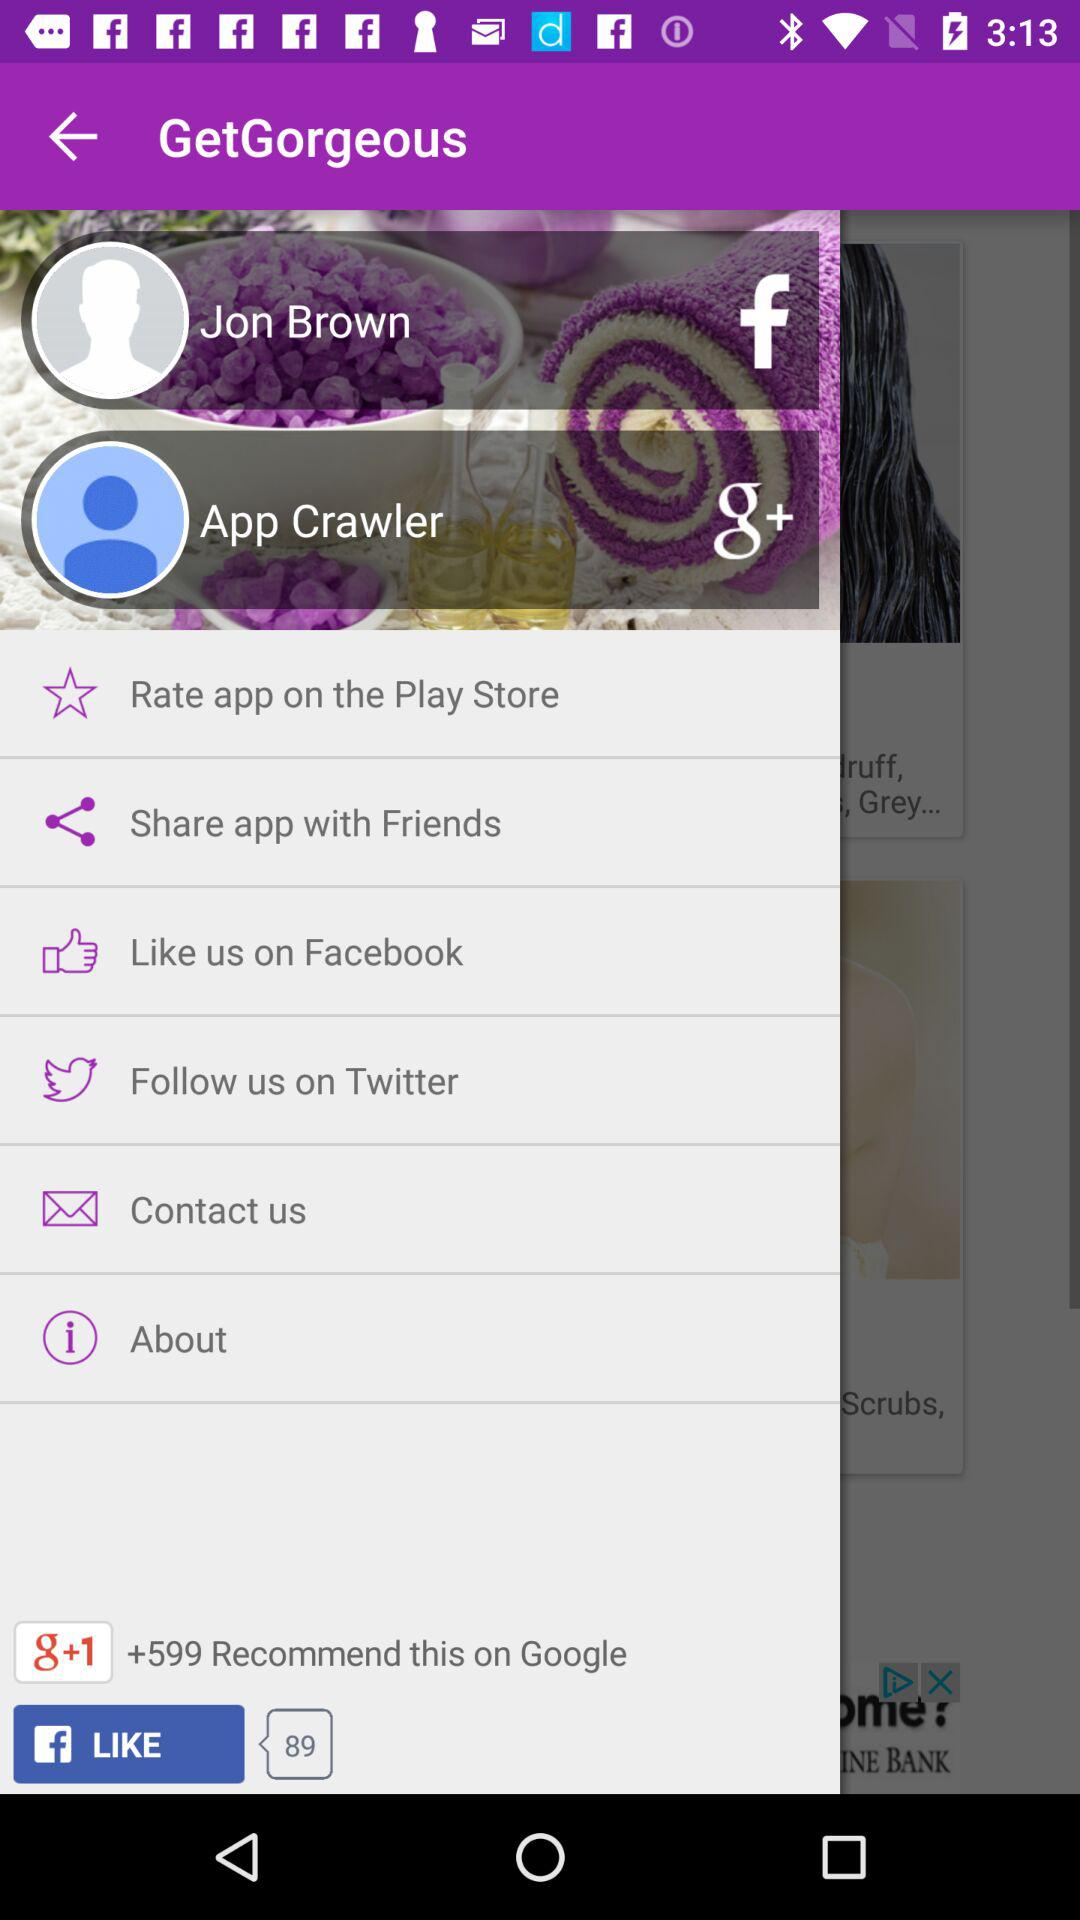What is Jon Brown's email address?
When the provided information is insufficient, respond with <no answer>. <no answer> 